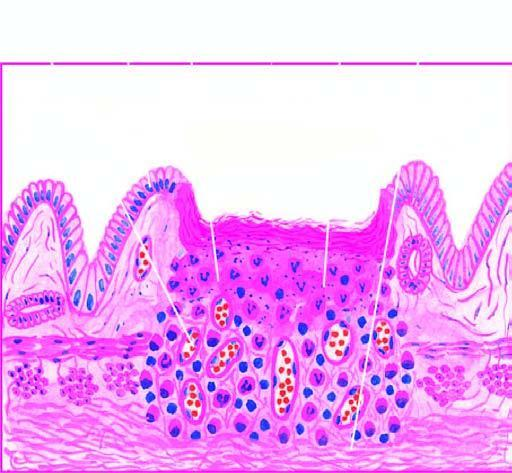re histologic zones of the ulcer illustrated in the diagram?
Answer the question using a single word or phrase. Yes 